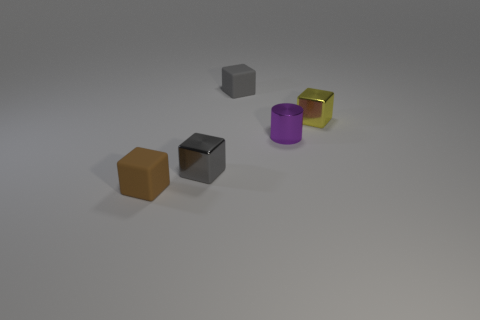Do the yellow block and the gray cube to the left of the small gray rubber object have the same material?
Make the answer very short. Yes. Are there fewer purple metallic things that are in front of the gray matte thing than small gray matte things?
Give a very brief answer. No. What number of other things are there of the same shape as the purple metallic object?
Your answer should be compact. 0. Is there any other thing of the same color as the small cylinder?
Offer a terse response. No. Do the cylinder and the tiny block that is left of the small gray metallic thing have the same color?
Your response must be concise. No. What number of other objects are there of the same size as the yellow object?
Your answer should be compact. 4. How many spheres are either large purple rubber objects or tiny yellow things?
Provide a succinct answer. 0. There is a tiny gray object in front of the tiny purple metallic thing; does it have the same shape as the tiny brown matte object?
Your answer should be compact. Yes. Is the number of tiny yellow blocks to the right of the tiny purple metal object greater than the number of tiny red cubes?
Provide a succinct answer. Yes. There is a metallic block that is the same size as the gray metallic thing; what is its color?
Ensure brevity in your answer.  Yellow. 